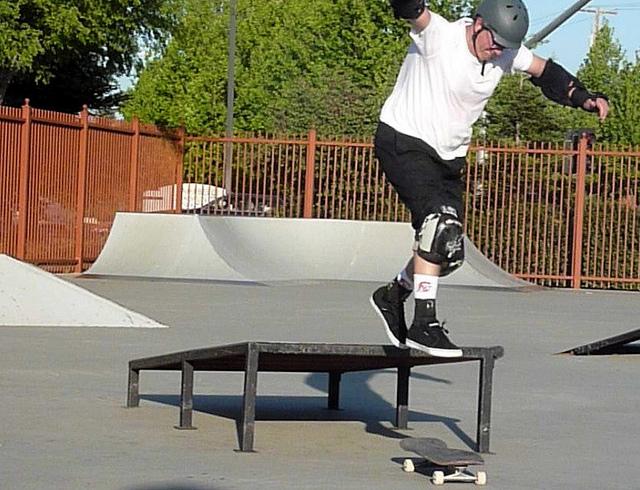What color is the man's shirt?
Quick response, please. White. Could he break his neck?
Be succinct. Yes. Is the man wearing sunglasses?
Give a very brief answer. No. What color are the skater's shoe laces?
Concise answer only. Black. Is this person in a skate park?
Short answer required. Yes. What safety gear is he wearing on his legs?
Keep it brief. Knee pads. 